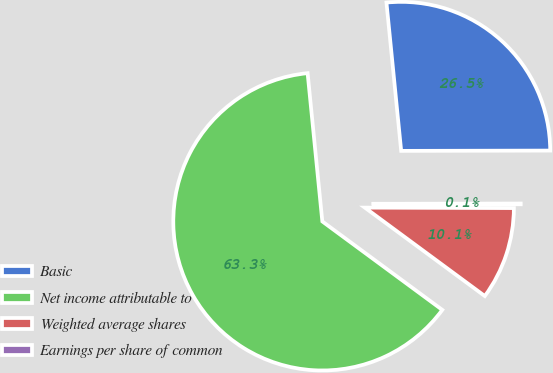<chart> <loc_0><loc_0><loc_500><loc_500><pie_chart><fcel>Basic<fcel>Net income attributable to<fcel>Weighted average shares<fcel>Earnings per share of common<nl><fcel>26.54%<fcel>63.31%<fcel>10.06%<fcel>0.08%<nl></chart> 